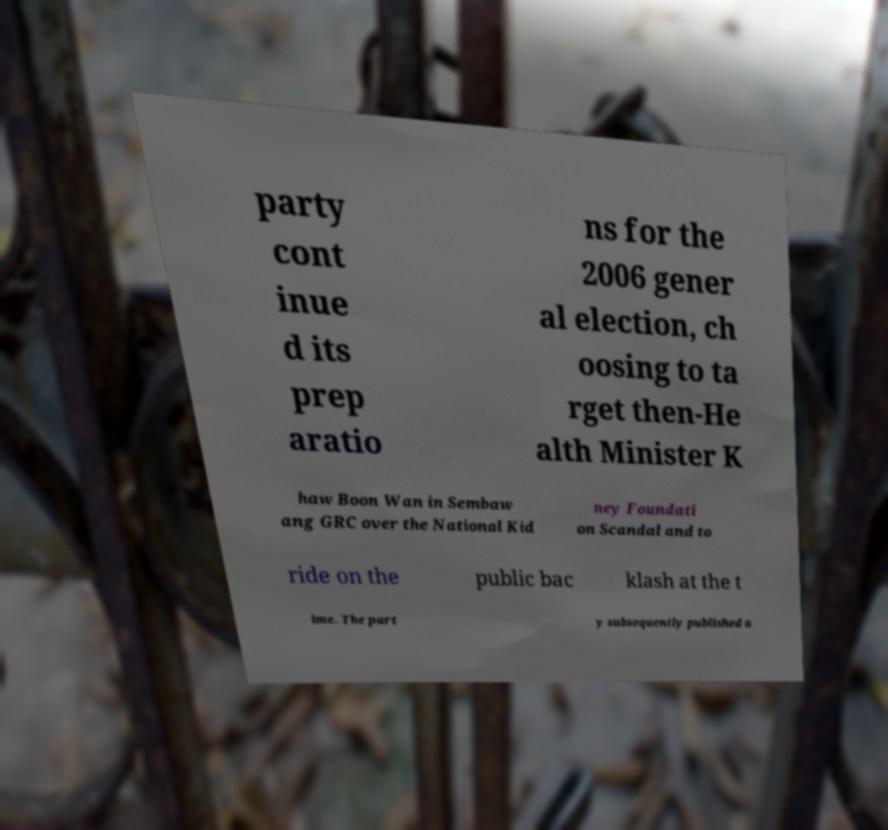I need the written content from this picture converted into text. Can you do that? party cont inue d its prep aratio ns for the 2006 gener al election, ch oosing to ta rget then-He alth Minister K haw Boon Wan in Sembaw ang GRC over the National Kid ney Foundati on Scandal and to ride on the public bac klash at the t ime. The part y subsequently published a 